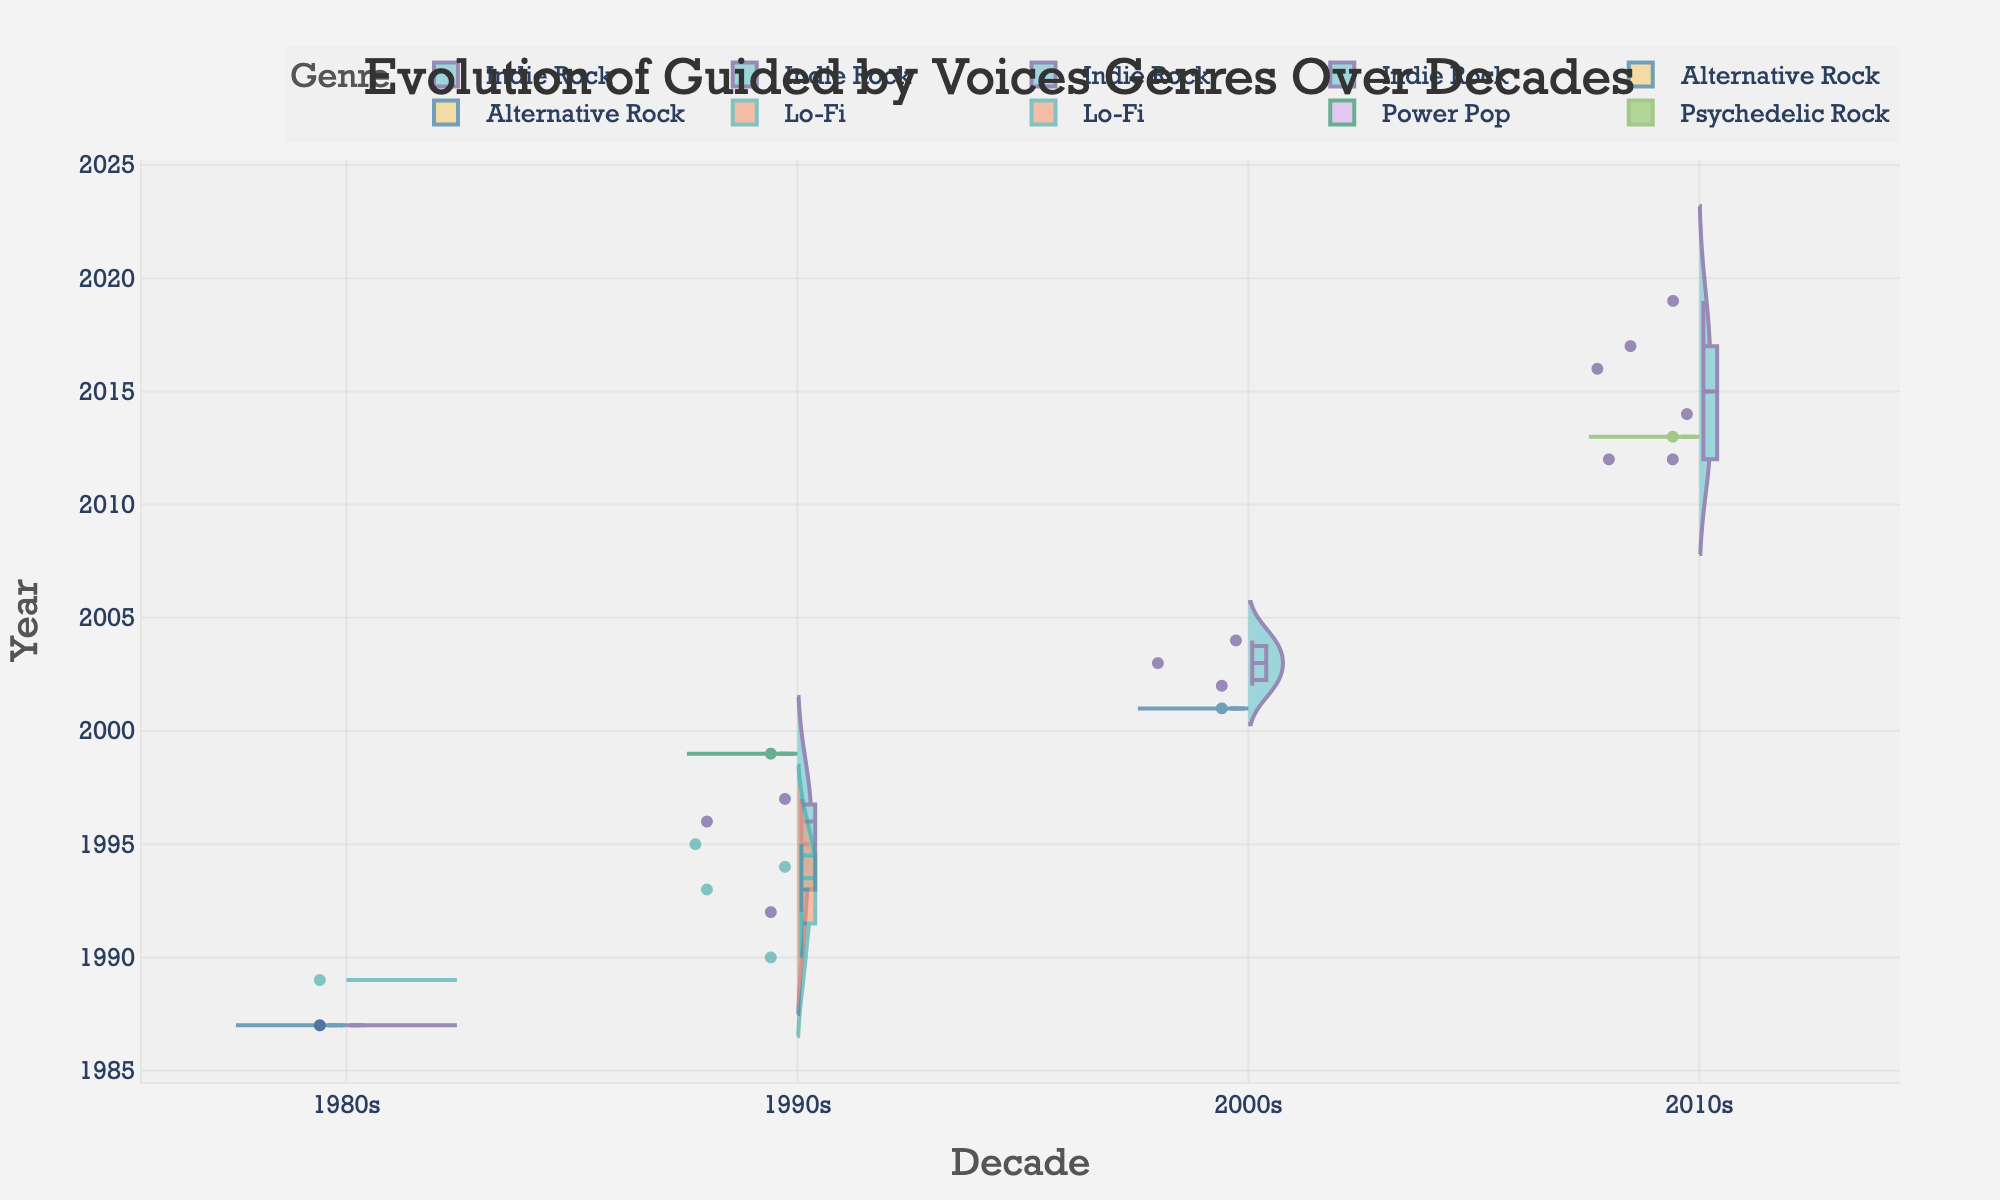How many albums were released by Guided by Voices in the 1980s? The Split Violin Chart shows data points along the y-axis, which represents the years. To find the number of albums released in the 1980s, locate the data points between 1980 and 1989.
Answer: 3 Which decade has the most varied genres of albums? By observing the Split Violin Chart, note the number of distinct segments in each decade. The 2000s show Indie Rock, Alternative Rock, Psychedelic Rock, Lo-Fi, and Power Pop genres.
Answer: 2000s What genre appears the most frequently in Guided by Voices' discography? Check the vertical sections of the Split Violin Chart and count how many times each genre appears across different decades. Indie Rock has the most occurrences.
Answer: Indie Rock How many albums were released in the 2010s and what are their genres? Identify the data points in the decade starting with 2010. The chart shows numerous data points, with genres being Indie Rock and Psychedelic Rock.
Answer: 6 (Indie Rock, Psychedelic Rock) Which genre is represented in the negative half of the Split Violin Chart? In the chart, the positive half has Indie Rock, Lo-Fi. The negative half shows genres like Alternative Rock, Power Pop, and Psychedelic Rock.
Answer: Alternative Rock, Power Pop, Psychedelic Rock What is the genre of the album released in 1999? Locate the year 1999 on the y-axis and check the genre corresponding to that data point.
Answer: Power Pop Which genre had its last album released in 1995? Identify genres from the chart and trace them to the last year they appear. Lo-Fi’s last album was released in 1995.
Answer: Lo-Fi Compare the frequency of releases between the 1990s and the 2000s. Which decade had more releases? Count the data points for each decade. The 1990s have more data points than the 2000s, indicating more releases.
Answer: 1990s 